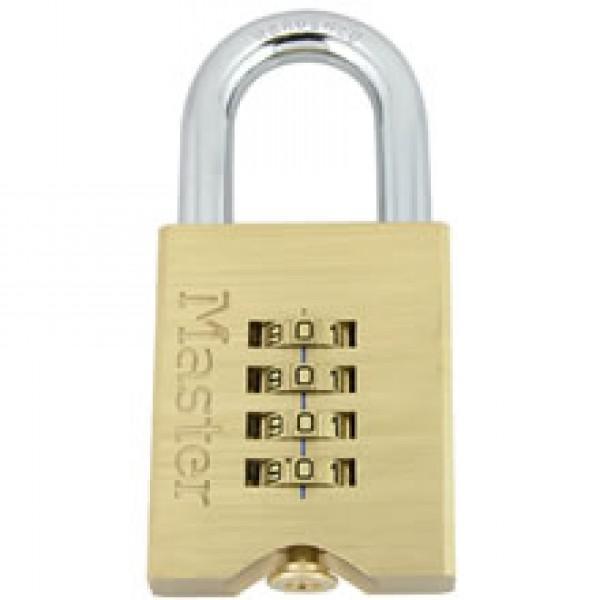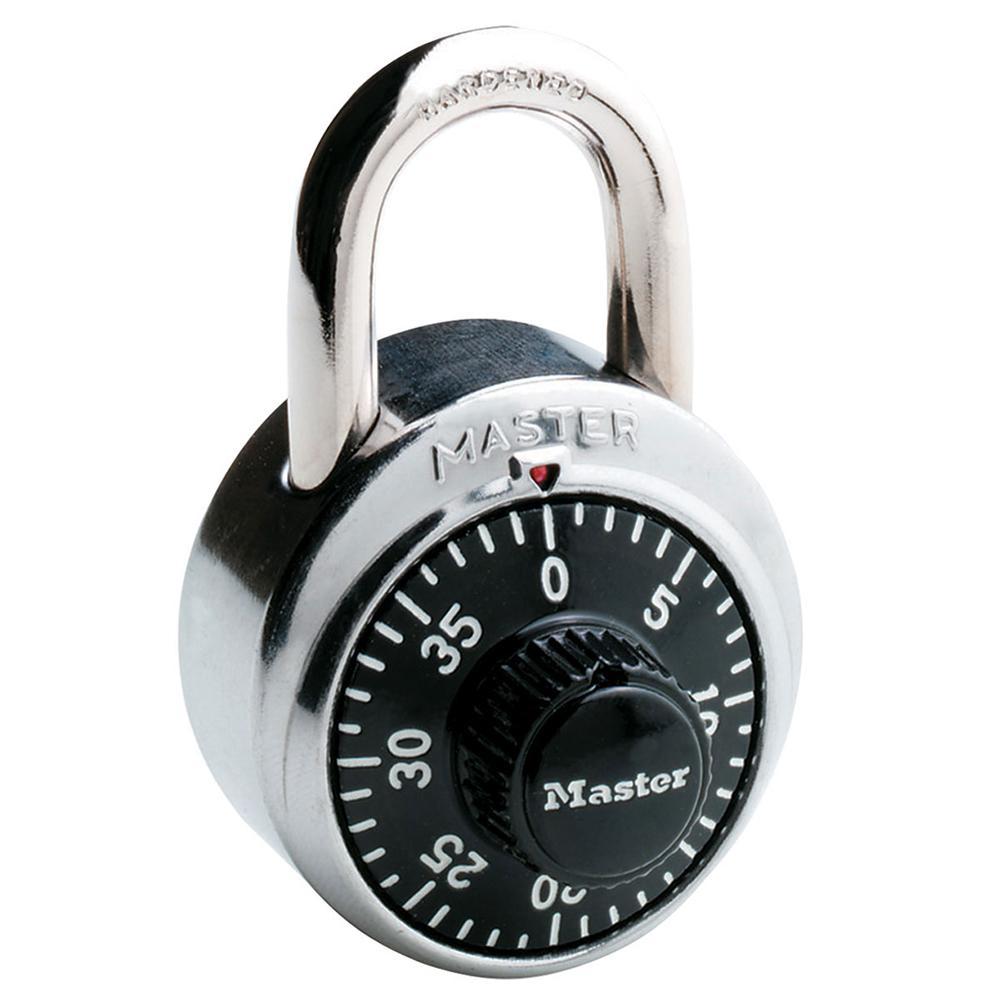The first image is the image on the left, the second image is the image on the right. Examine the images to the left and right. Is the description "One lock is gold and squarish, and the other lock is round with a black face." accurate? Answer yes or no. Yes. The first image is the image on the left, the second image is the image on the right. Analyze the images presented: Is the assertion "Each of two different colored padlocks is a similar shape, but one has number belts on the front and side, while the other has number belts on the bottom." valid? Answer yes or no. No. 